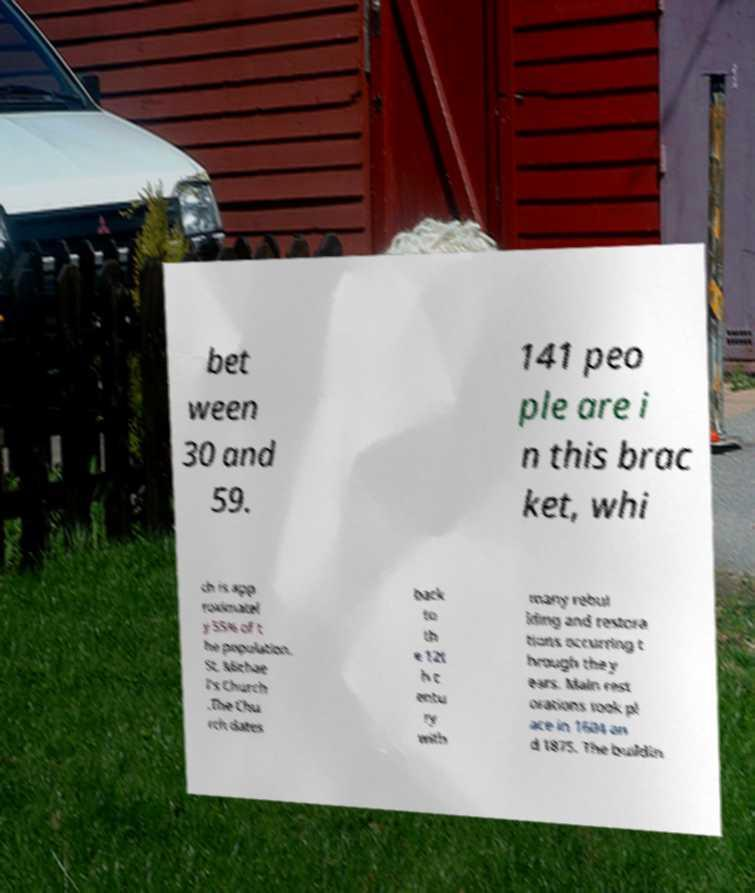What messages or text are displayed in this image? I need them in a readable, typed format. bet ween 30 and 59. 141 peo ple are i n this brac ket, whi ch is app roximatel y 55% of t he population. St. Michae l's Church .The Chu rch dates back to th e 12t h c entu ry with many rebui lding and restora tions occurring t hrough the y ears. Main rest orations took pl ace in 1604 an d 1875. The buildin 